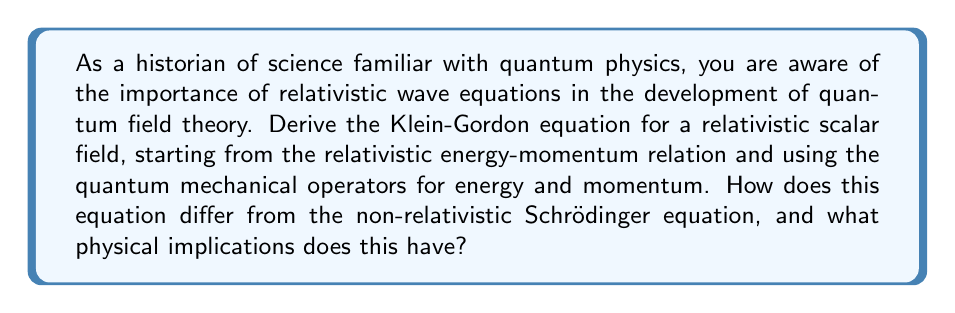Solve this math problem. To derive the Klein-Gordon equation, we'll follow these steps:

1) Begin with the relativistic energy-momentum relation:
   $$E^2 = p^2c^2 + m^2c^4$$

2) In quantum mechanics, we use the following operators:
   Energy: $E \rightarrow i\hbar\frac{\partial}{\partial t}$
   Momentum: $\mathbf{p} \rightarrow -i\hbar\nabla$

3) Substitute these operators into the energy-momentum relation:
   $$(i\hbar\frac{\partial}{\partial t})^2 = (-i\hbar\nabla)^2c^2 + m^2c^4$$

4) Simplify:
   $$-\hbar^2\frac{\partial^2}{\partial t^2} = -\hbar^2c^2\nabla^2 + m^2c^4$$

5) Divide both sides by $-\hbar^2c^2$:
   $$\frac{1}{c^2}\frac{\partial^2}{\partial t^2} = \nabla^2 - \frac{m^2c^2}{\hbar^2}$$

6) Rearrange to get the Klein-Gordon equation:
   $$\frac{1}{c^2}\frac{\partial^2\phi}{\partial t^2} - \nabla^2\phi + \frac{m^2c^2}{\hbar^2}\phi = 0$$

Where $\phi$ is the scalar field.

The Klein-Gordon equation differs from the Schrödinger equation in several ways:

1) It's second-order in time, while the Schrödinger equation is first-order.
2) It's relativistically invariant, unlike the Schrödinger equation.
3) It describes spin-0 particles, while the Schrödinger equation describes non-relativistic particles.

Physical implications:
1) The Klein-Gordon equation allows for negative energy solutions, which led to the prediction of antiparticles.
2) It can describe particles with zero spin, such as the Higgs boson.
3) The equation's relativistic nature means it correctly describes particles moving at high speeds, near the speed of light.
Answer: The Klein-Gordon equation for a relativistic scalar field $\phi$ is:

$$\frac{1}{c^2}\frac{\partial^2\phi}{\partial t^2} - \nabla^2\phi + \frac{m^2c^2}{\hbar^2}\phi = 0$$

This equation is relativistically invariant, second-order in time, and describes spin-0 particles. It allows for negative energy solutions, leading to the prediction of antiparticles, and correctly describes particles moving at relativistic speeds. 